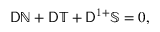Convert formula to latex. <formula><loc_0><loc_0><loc_500><loc_500>D \mathbb { N } + D \mathbb { T } + D ^ { 1 + } \mathbb { S } = 0 ,</formula> 